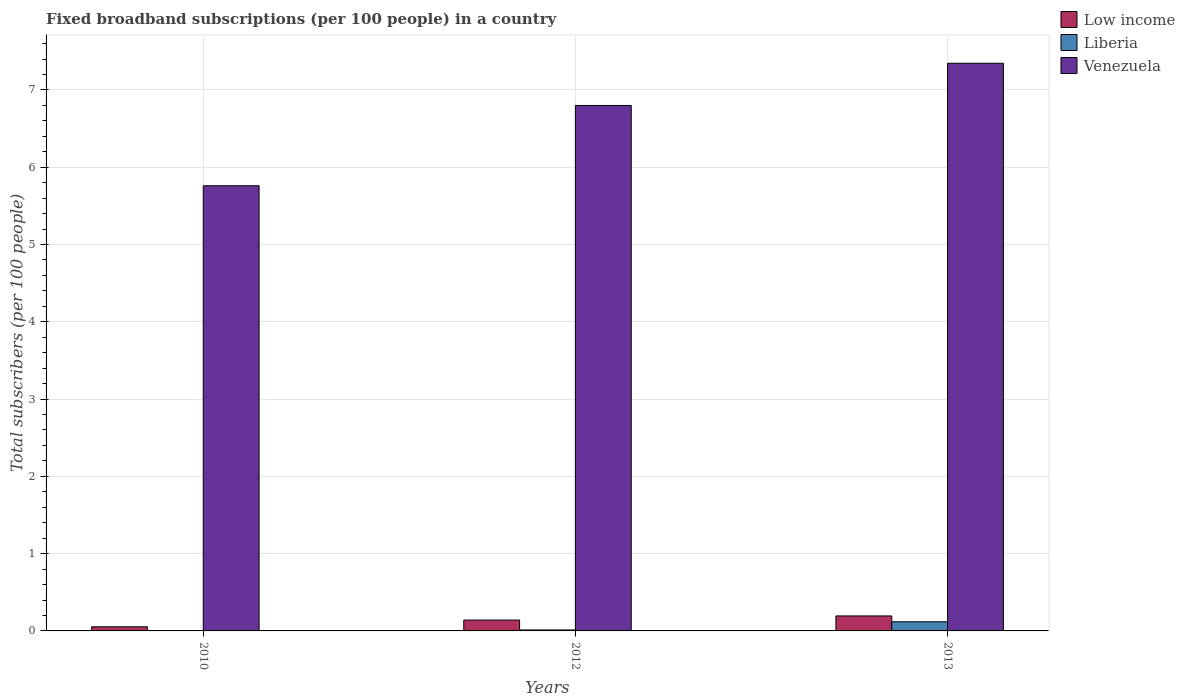Are the number of bars per tick equal to the number of legend labels?
Give a very brief answer. Yes. How many bars are there on the 2nd tick from the left?
Offer a terse response. 3. How many bars are there on the 1st tick from the right?
Provide a short and direct response. 3. What is the label of the 3rd group of bars from the left?
Ensure brevity in your answer.  2013. What is the number of broadband subscriptions in Liberia in 2012?
Offer a very short reply. 0.01. Across all years, what is the maximum number of broadband subscriptions in Venezuela?
Offer a terse response. 7.35. Across all years, what is the minimum number of broadband subscriptions in Liberia?
Offer a terse response. 0. In which year was the number of broadband subscriptions in Low income maximum?
Make the answer very short. 2013. In which year was the number of broadband subscriptions in Liberia minimum?
Ensure brevity in your answer.  2010. What is the total number of broadband subscriptions in Liberia in the graph?
Your response must be concise. 0.14. What is the difference between the number of broadband subscriptions in Low income in 2010 and that in 2013?
Provide a short and direct response. -0.14. What is the difference between the number of broadband subscriptions in Liberia in 2010 and the number of broadband subscriptions in Low income in 2012?
Your response must be concise. -0.14. What is the average number of broadband subscriptions in Liberia per year?
Give a very brief answer. 0.05. In the year 2010, what is the difference between the number of broadband subscriptions in Liberia and number of broadband subscriptions in Low income?
Provide a succinct answer. -0.05. What is the ratio of the number of broadband subscriptions in Liberia in 2010 to that in 2012?
Keep it short and to the point. 0.38. Is the number of broadband subscriptions in Liberia in 2010 less than that in 2012?
Ensure brevity in your answer.  Yes. Is the difference between the number of broadband subscriptions in Liberia in 2010 and 2013 greater than the difference between the number of broadband subscriptions in Low income in 2010 and 2013?
Keep it short and to the point. Yes. What is the difference between the highest and the second highest number of broadband subscriptions in Venezuela?
Your answer should be compact. 0.55. What is the difference between the highest and the lowest number of broadband subscriptions in Low income?
Offer a very short reply. 0.14. In how many years, is the number of broadband subscriptions in Low income greater than the average number of broadband subscriptions in Low income taken over all years?
Your answer should be very brief. 2. Is the sum of the number of broadband subscriptions in Venezuela in 2012 and 2013 greater than the maximum number of broadband subscriptions in Low income across all years?
Offer a terse response. Yes. What does the 2nd bar from the left in 2010 represents?
Offer a very short reply. Liberia. What does the 3rd bar from the right in 2012 represents?
Offer a very short reply. Low income. Is it the case that in every year, the sum of the number of broadband subscriptions in Low income and number of broadband subscriptions in Venezuela is greater than the number of broadband subscriptions in Liberia?
Offer a very short reply. Yes. What is the difference between two consecutive major ticks on the Y-axis?
Keep it short and to the point. 1. Are the values on the major ticks of Y-axis written in scientific E-notation?
Your answer should be very brief. No. Does the graph contain any zero values?
Make the answer very short. No. Does the graph contain grids?
Your response must be concise. Yes. Where does the legend appear in the graph?
Your answer should be compact. Top right. What is the title of the graph?
Your answer should be compact. Fixed broadband subscriptions (per 100 people) in a country. What is the label or title of the Y-axis?
Your answer should be compact. Total subscribers (per 100 people). What is the Total subscribers (per 100 people) in Low income in 2010?
Keep it short and to the point. 0.05. What is the Total subscribers (per 100 people) in Liberia in 2010?
Provide a succinct answer. 0. What is the Total subscribers (per 100 people) of Venezuela in 2010?
Offer a very short reply. 5.76. What is the Total subscribers (per 100 people) in Low income in 2012?
Provide a short and direct response. 0.14. What is the Total subscribers (per 100 people) of Liberia in 2012?
Provide a succinct answer. 0.01. What is the Total subscribers (per 100 people) in Venezuela in 2012?
Keep it short and to the point. 6.8. What is the Total subscribers (per 100 people) in Low income in 2013?
Your answer should be compact. 0.19. What is the Total subscribers (per 100 people) of Liberia in 2013?
Provide a short and direct response. 0.12. What is the Total subscribers (per 100 people) of Venezuela in 2013?
Your answer should be compact. 7.35. Across all years, what is the maximum Total subscribers (per 100 people) in Low income?
Offer a very short reply. 0.19. Across all years, what is the maximum Total subscribers (per 100 people) in Liberia?
Keep it short and to the point. 0.12. Across all years, what is the maximum Total subscribers (per 100 people) in Venezuela?
Provide a succinct answer. 7.35. Across all years, what is the minimum Total subscribers (per 100 people) of Low income?
Your answer should be very brief. 0.05. Across all years, what is the minimum Total subscribers (per 100 people) of Liberia?
Your answer should be very brief. 0. Across all years, what is the minimum Total subscribers (per 100 people) in Venezuela?
Provide a short and direct response. 5.76. What is the total Total subscribers (per 100 people) of Low income in the graph?
Your response must be concise. 0.39. What is the total Total subscribers (per 100 people) of Liberia in the graph?
Give a very brief answer. 0.14. What is the total Total subscribers (per 100 people) in Venezuela in the graph?
Offer a terse response. 19.91. What is the difference between the Total subscribers (per 100 people) in Low income in 2010 and that in 2012?
Provide a short and direct response. -0.09. What is the difference between the Total subscribers (per 100 people) in Liberia in 2010 and that in 2012?
Give a very brief answer. -0.01. What is the difference between the Total subscribers (per 100 people) of Venezuela in 2010 and that in 2012?
Give a very brief answer. -1.04. What is the difference between the Total subscribers (per 100 people) in Low income in 2010 and that in 2013?
Your answer should be very brief. -0.14. What is the difference between the Total subscribers (per 100 people) of Liberia in 2010 and that in 2013?
Ensure brevity in your answer.  -0.11. What is the difference between the Total subscribers (per 100 people) of Venezuela in 2010 and that in 2013?
Provide a succinct answer. -1.58. What is the difference between the Total subscribers (per 100 people) of Low income in 2012 and that in 2013?
Your answer should be very brief. -0.05. What is the difference between the Total subscribers (per 100 people) of Liberia in 2012 and that in 2013?
Provide a short and direct response. -0.11. What is the difference between the Total subscribers (per 100 people) in Venezuela in 2012 and that in 2013?
Make the answer very short. -0.55. What is the difference between the Total subscribers (per 100 people) of Low income in 2010 and the Total subscribers (per 100 people) of Liberia in 2012?
Ensure brevity in your answer.  0.04. What is the difference between the Total subscribers (per 100 people) in Low income in 2010 and the Total subscribers (per 100 people) in Venezuela in 2012?
Your answer should be very brief. -6.75. What is the difference between the Total subscribers (per 100 people) of Liberia in 2010 and the Total subscribers (per 100 people) of Venezuela in 2012?
Ensure brevity in your answer.  -6.79. What is the difference between the Total subscribers (per 100 people) of Low income in 2010 and the Total subscribers (per 100 people) of Liberia in 2013?
Give a very brief answer. -0.06. What is the difference between the Total subscribers (per 100 people) of Low income in 2010 and the Total subscribers (per 100 people) of Venezuela in 2013?
Your response must be concise. -7.29. What is the difference between the Total subscribers (per 100 people) of Liberia in 2010 and the Total subscribers (per 100 people) of Venezuela in 2013?
Your answer should be compact. -7.34. What is the difference between the Total subscribers (per 100 people) in Low income in 2012 and the Total subscribers (per 100 people) in Liberia in 2013?
Offer a terse response. 0.02. What is the difference between the Total subscribers (per 100 people) of Low income in 2012 and the Total subscribers (per 100 people) of Venezuela in 2013?
Give a very brief answer. -7.21. What is the difference between the Total subscribers (per 100 people) of Liberia in 2012 and the Total subscribers (per 100 people) of Venezuela in 2013?
Make the answer very short. -7.33. What is the average Total subscribers (per 100 people) in Low income per year?
Provide a succinct answer. 0.13. What is the average Total subscribers (per 100 people) of Liberia per year?
Offer a very short reply. 0.05. What is the average Total subscribers (per 100 people) in Venezuela per year?
Give a very brief answer. 6.64. In the year 2010, what is the difference between the Total subscribers (per 100 people) of Low income and Total subscribers (per 100 people) of Liberia?
Ensure brevity in your answer.  0.05. In the year 2010, what is the difference between the Total subscribers (per 100 people) of Low income and Total subscribers (per 100 people) of Venezuela?
Your answer should be very brief. -5.71. In the year 2010, what is the difference between the Total subscribers (per 100 people) in Liberia and Total subscribers (per 100 people) in Venezuela?
Provide a short and direct response. -5.76. In the year 2012, what is the difference between the Total subscribers (per 100 people) of Low income and Total subscribers (per 100 people) of Liberia?
Give a very brief answer. 0.13. In the year 2012, what is the difference between the Total subscribers (per 100 people) in Low income and Total subscribers (per 100 people) in Venezuela?
Your response must be concise. -6.66. In the year 2012, what is the difference between the Total subscribers (per 100 people) of Liberia and Total subscribers (per 100 people) of Venezuela?
Offer a terse response. -6.79. In the year 2013, what is the difference between the Total subscribers (per 100 people) of Low income and Total subscribers (per 100 people) of Liberia?
Provide a short and direct response. 0.08. In the year 2013, what is the difference between the Total subscribers (per 100 people) of Low income and Total subscribers (per 100 people) of Venezuela?
Keep it short and to the point. -7.15. In the year 2013, what is the difference between the Total subscribers (per 100 people) of Liberia and Total subscribers (per 100 people) of Venezuela?
Give a very brief answer. -7.23. What is the ratio of the Total subscribers (per 100 people) in Low income in 2010 to that in 2012?
Offer a very short reply. 0.38. What is the ratio of the Total subscribers (per 100 people) of Liberia in 2010 to that in 2012?
Offer a very short reply. 0.38. What is the ratio of the Total subscribers (per 100 people) of Venezuela in 2010 to that in 2012?
Keep it short and to the point. 0.85. What is the ratio of the Total subscribers (per 100 people) in Low income in 2010 to that in 2013?
Your response must be concise. 0.28. What is the ratio of the Total subscribers (per 100 people) of Liberia in 2010 to that in 2013?
Make the answer very short. 0.04. What is the ratio of the Total subscribers (per 100 people) in Venezuela in 2010 to that in 2013?
Offer a very short reply. 0.78. What is the ratio of the Total subscribers (per 100 people) of Low income in 2012 to that in 2013?
Your response must be concise. 0.72. What is the ratio of the Total subscribers (per 100 people) of Liberia in 2012 to that in 2013?
Ensure brevity in your answer.  0.11. What is the ratio of the Total subscribers (per 100 people) of Venezuela in 2012 to that in 2013?
Offer a very short reply. 0.93. What is the difference between the highest and the second highest Total subscribers (per 100 people) of Low income?
Ensure brevity in your answer.  0.05. What is the difference between the highest and the second highest Total subscribers (per 100 people) of Liberia?
Provide a succinct answer. 0.11. What is the difference between the highest and the second highest Total subscribers (per 100 people) of Venezuela?
Your response must be concise. 0.55. What is the difference between the highest and the lowest Total subscribers (per 100 people) in Low income?
Ensure brevity in your answer.  0.14. What is the difference between the highest and the lowest Total subscribers (per 100 people) of Liberia?
Offer a terse response. 0.11. What is the difference between the highest and the lowest Total subscribers (per 100 people) of Venezuela?
Give a very brief answer. 1.58. 